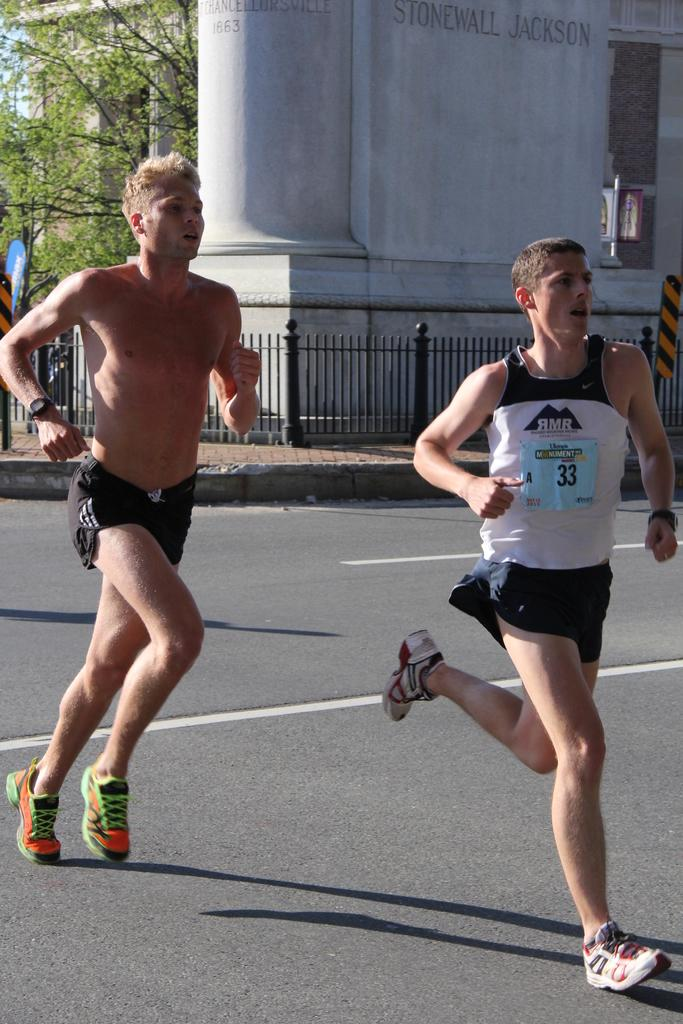What are the two men in the image doing? The two men in the image are running. On what surface are the men running? The men are running on a road. What can be seen in the background of the image? There is a building, a wall with text, a sign board, a tree, and the sky visible in the background of the image. What type of toothpaste is being advertised on the sign board in the men in the image? There is no toothpaste or sign advertising toothpaste present in the image. What type of oil can be seen dripping from the tree in the image? There is no oil or indication of oil dripping from the tree in the image. 